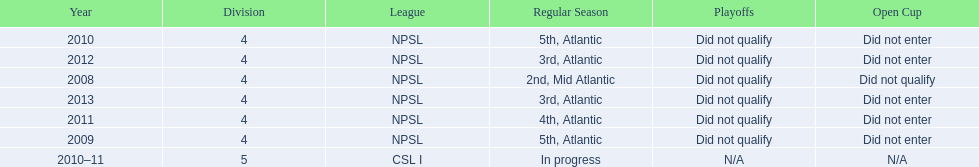I'm looking to parse the entire table for insights. Could you assist me with that? {'header': ['Year', 'Division', 'League', 'Regular Season', 'Playoffs', 'Open Cup'], 'rows': [['2010', '4', 'NPSL', '5th, Atlantic', 'Did not qualify', 'Did not enter'], ['2012', '4', 'NPSL', '3rd, Atlantic', 'Did not qualify', 'Did not enter'], ['2008', '4', 'NPSL', '2nd, Mid Atlantic', 'Did not qualify', 'Did not qualify'], ['2013', '4', 'NPSL', '3rd, Atlantic', 'Did not qualify', 'Did not enter'], ['2011', '4', 'NPSL', '4th, Atlantic', 'Did not qualify', 'Did not enter'], ['2009', '4', 'NPSL', '5th, Atlantic', 'Did not qualify', 'Did not enter'], ['2010–11', '5', 'CSL I', 'In progress', 'N/A', 'N/A']]} What are the leagues? NPSL, NPSL, NPSL, CSL I, NPSL, NPSL, NPSL. Of these, what league is not npsl? CSL I. 